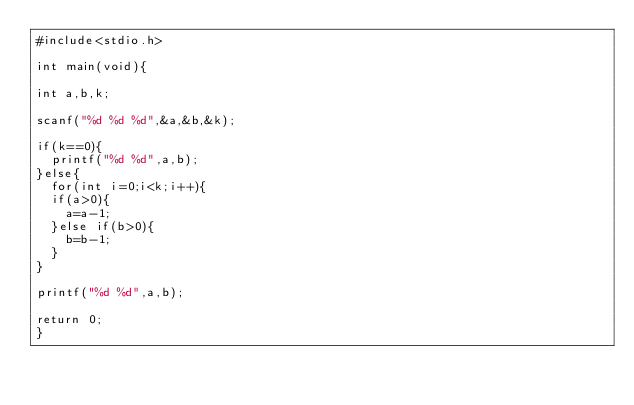<code> <loc_0><loc_0><loc_500><loc_500><_C_>#include<stdio.h>

int main(void){

int a,b,k;

scanf("%d %d %d",&a,&b,&k);

if(k==0){
  printf("%d %d",a,b);
}else{
  for(int i=0;i<k;i++){
  if(a>0){
    a=a-1;
  }else if(b>0){
    b=b-1;
  }
}

printf("%d %d",a,b);

return 0;
}</code> 